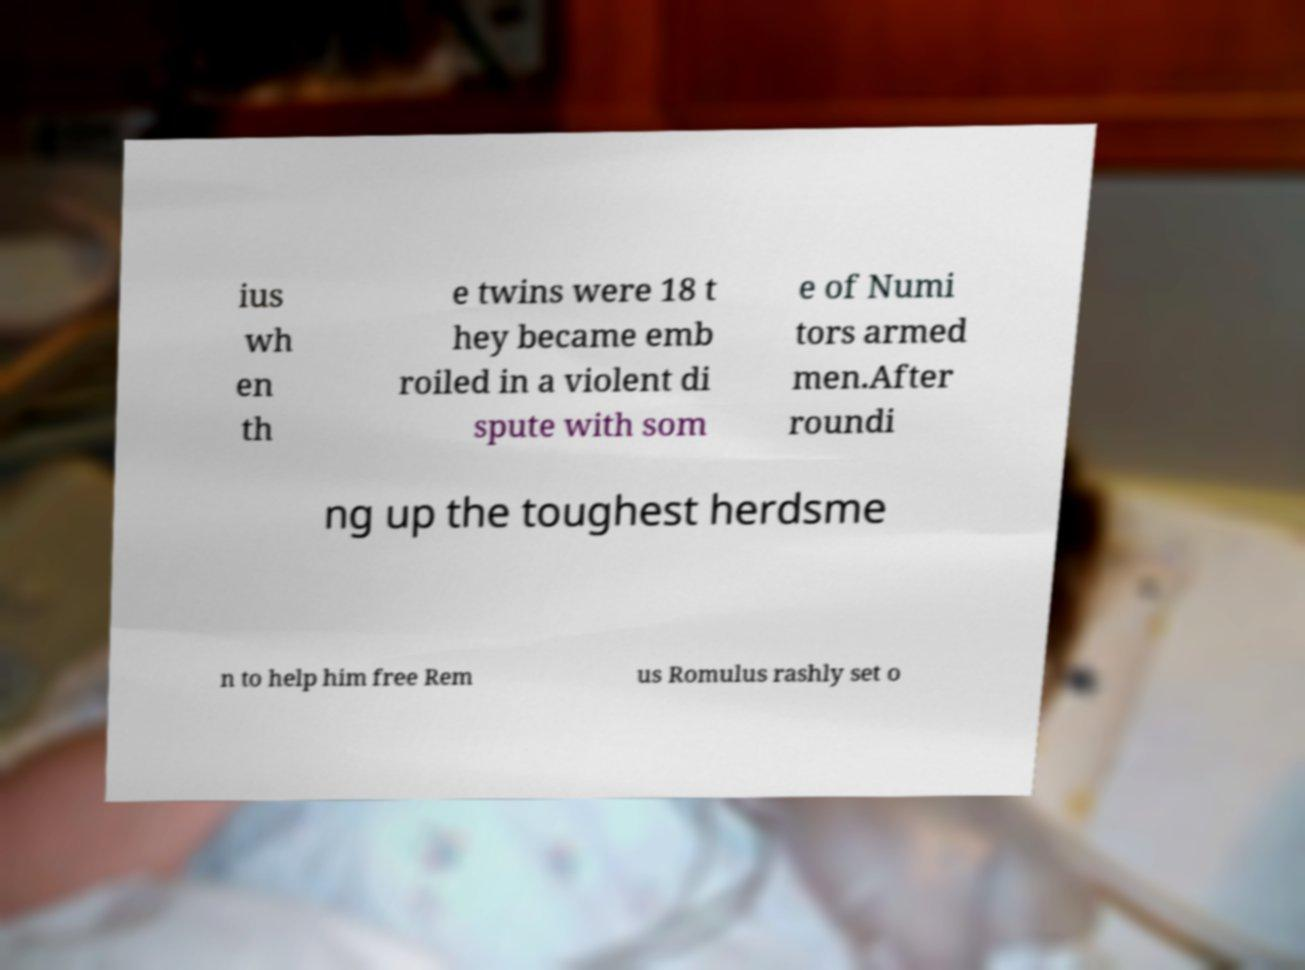There's text embedded in this image that I need extracted. Can you transcribe it verbatim? ius wh en th e twins were 18 t hey became emb roiled in a violent di spute with som e of Numi tors armed men.After roundi ng up the toughest herdsme n to help him free Rem us Romulus rashly set o 